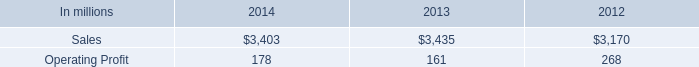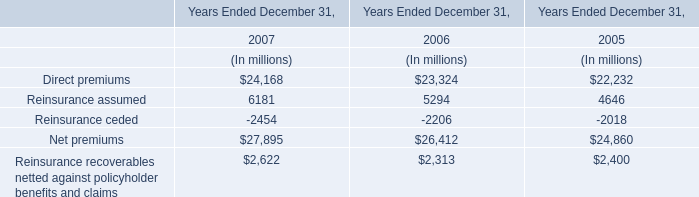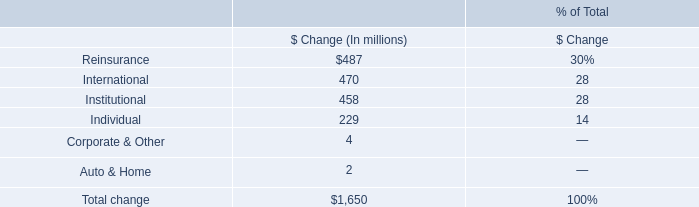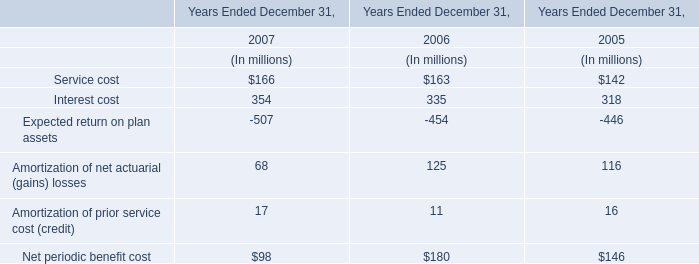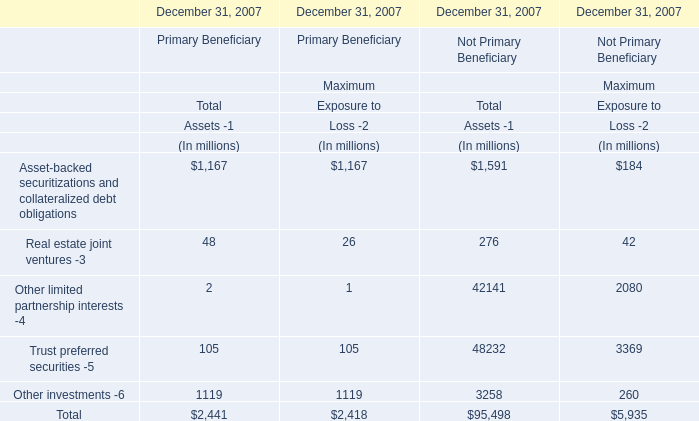How many Maximum Exposure to Loss -2 exceed the average of Maximum Exposure to Loss -2 in 2007? 
Answer: 2. 